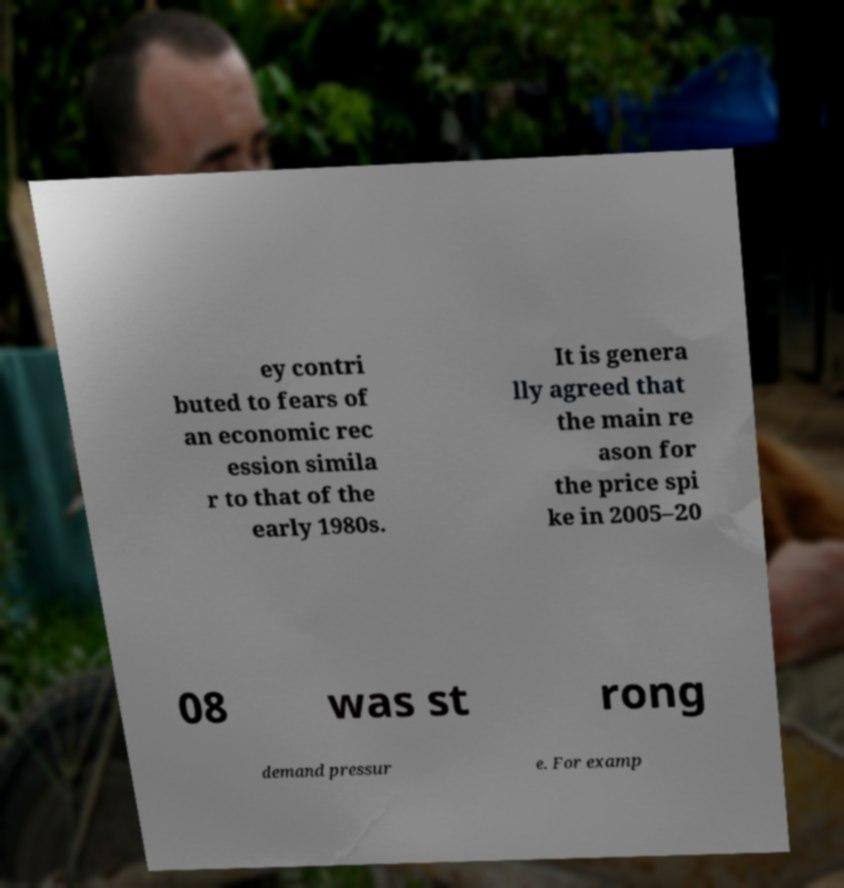Could you assist in decoding the text presented in this image and type it out clearly? ey contri buted to fears of an economic rec ession simila r to that of the early 1980s. It is genera lly agreed that the main re ason for the price spi ke in 2005–20 08 was st rong demand pressur e. For examp 